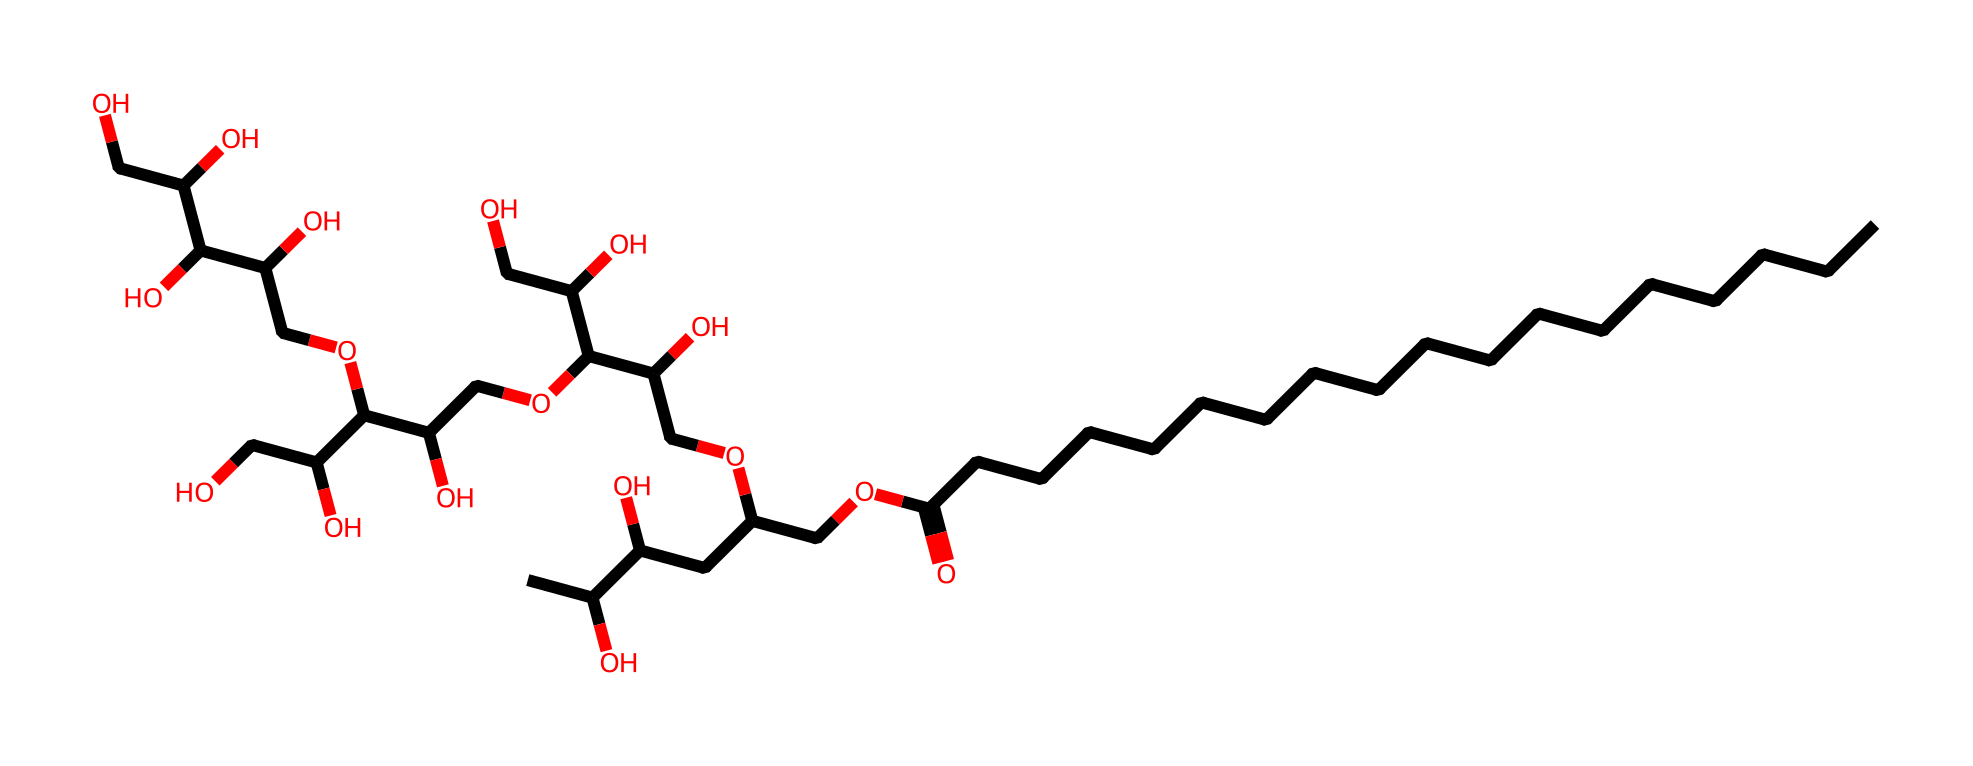What is the primary functional group in polysorbate 80? The SMILES representation indicates the presence of carboxylic acid (evident from the -COOH part) among other functional groups. This is identified by the carbon attached to a double bonded oxygen and a hydroxyl group.
Answer: carboxylic acid How many carbon atoms are present in the longest carbon chain of polysorbate 80? Upon examining the carbon chain in the SMILES, the longest continuous chain can be counted, which consists of 18 carbon atoms. This is identifiable as there are no branching points in that segment.
Answer: 18 What type of surfactant is polysorbate 80? Polysorbate 80 is a non-ionic surfactant, which can be inferred from its structure lacking any ionizable groups and its characteristic polyoxyethylene chains.
Answer: non-ionic How many hydroxyl (-OH) groups does polysorbate 80 contain? By analyzing the SMILES structure and counting the -OH groups, there are five hydroxyl groups present that are responsible for the hydrophilicity of the molecule.
Answer: 5 What is the molecular weight category of polysorbate 80? Estimating from its structure, polysorbate 80 falls into the category of larger molecules with a molecular weight exceeding 1000 grams per mole based on its numerous carbon and oxygen atoms.
Answer: >1000 g/mol How does the hydrophilic-lipophilic balance (HLB) of polysorbate 80 affect its emulsifying properties? Given the presence of both hydrophilic polyoxyethylene chains and lipophilic fatty acid chains in the structure, polysorbate 80 has a balanced HLB that enables it to stabilize oil-in-water emulsions effectively.
Answer: stabilizes oil-in-water emulsions 